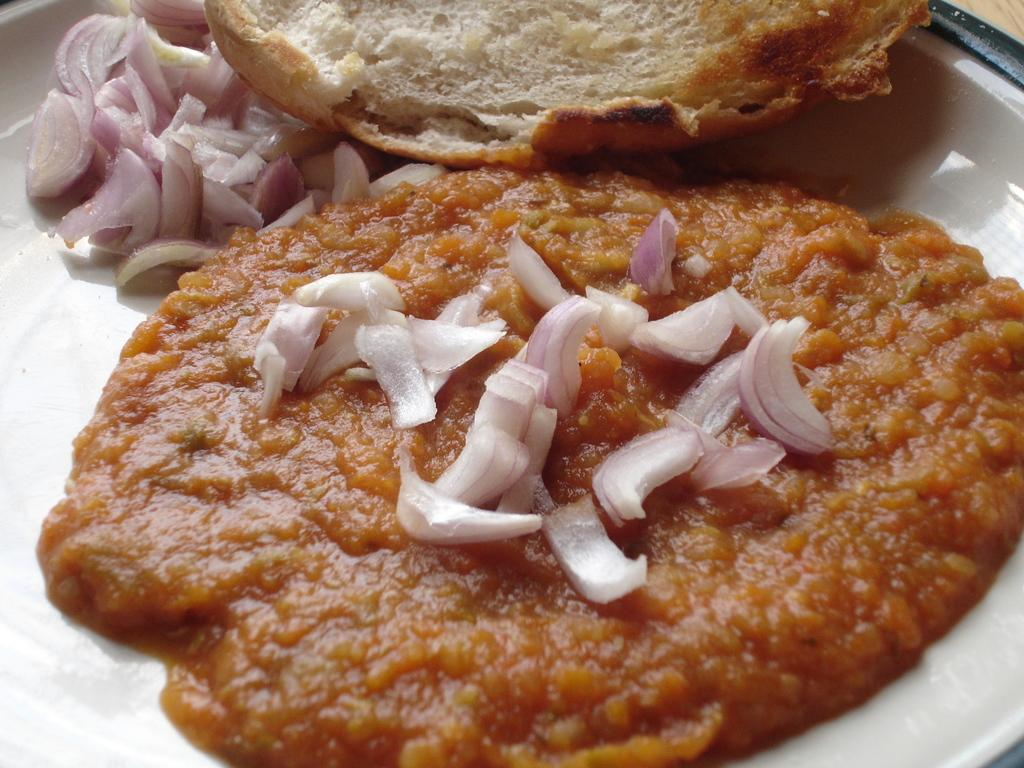What is on the plate that is visible in the image? The plate contains Pav bhaji in the image. What accompanies the Pav bhaji on the plate? Onions are present on the plate. What type of record is being played on the stove in the image? There is no record or stove present in the image; it features a plate with Pav bhaji and onions. How does the elbow contribute to the preparation of the Pav bhaji in the image? There is no elbow involved in the preparation or presentation of the Pav bhaji in the image. 